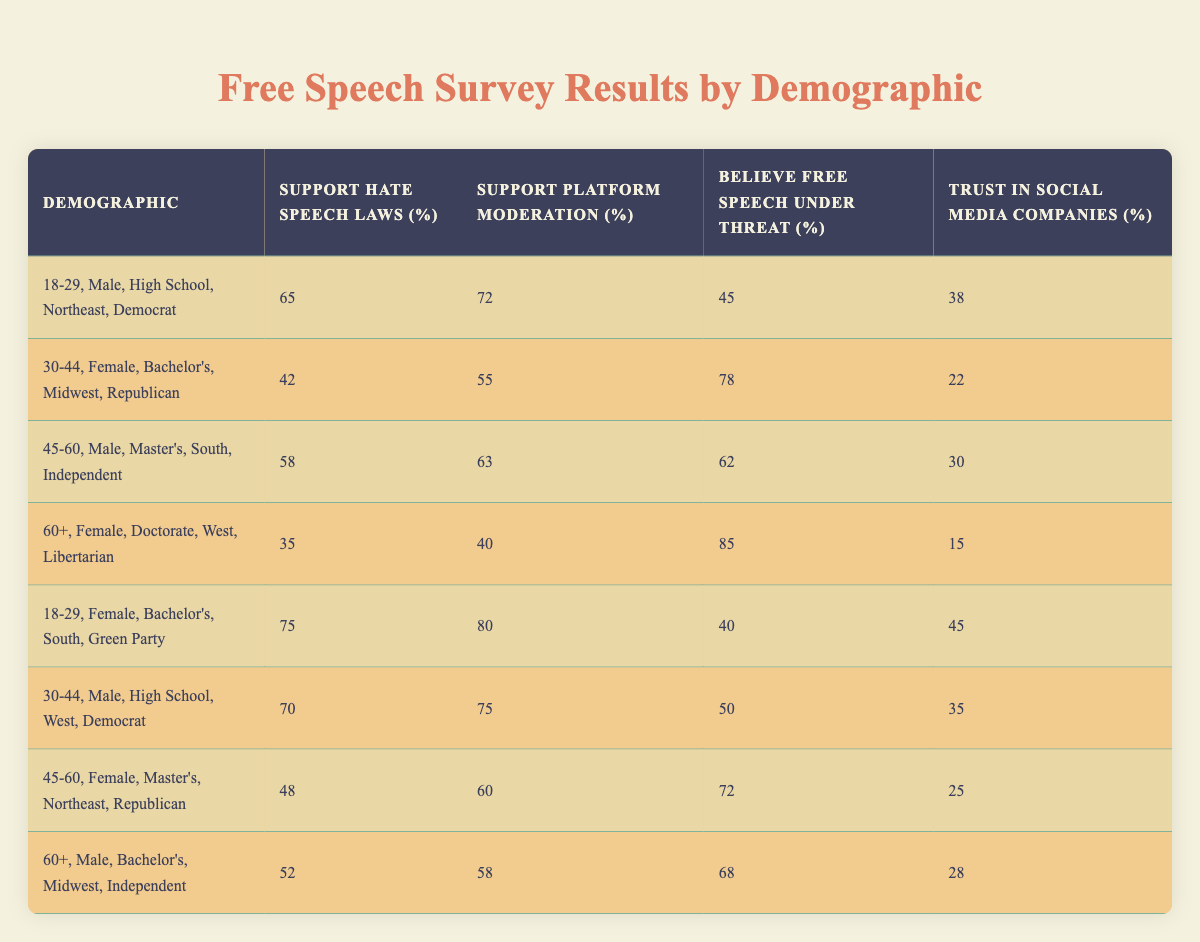What is the highest percentage of support for hate speech laws among the demographics? The demographics with the highest support for hate speech laws is the "18-29, Female, Bachelor's, South, Green Party" at 75%.
Answer: 75 Which demographic believes that free speech is under threat the most? The demographic with the highest belief that free speech is under threat is the "60+, Female, Doctorate, West, Libertarian" at 85%.
Answer: 85 What is the average percentage of trust in social media companies across all demographics? To find the average, add all the trust percentages: (38 + 22 + 30 + 15 + 45 + 35 + 25 + 28) = 238. Then, divide by the number of demographics, which is 8. So, the average is 238/8 = 29.75.
Answer: 29.75 Is there a demographic that has both high support for platform moderation and high belief that free speech is under threat? Yes, the demographic "30-44, Female, Bachelor's, Midwest, Republican" has a support for platform moderation of 55% and a belief that free speech is under threat of 78%, which indicates both points.
Answer: Yes What is the difference in percentage points for support for platform moderation between the youngest (18-29) male and female demographics? The support for platform moderation for "18-29, Male, High School, Northeast, Democrat" is 72%, and for "18-29, Female, Bachelor's, South, Green Party" it is 80%. The difference is calculated as 80% - 72% = 8%.
Answer: 8% Which demographic combination has the lowest trust in social media companies? The demographic with the lowest trust in social media companies is "60+, Female, Doctorate, West, Libertarian" at 15%.
Answer: 15 What is the combined percentage of support for hate speech laws for both males in the 30-44 age category? The support percentages for males in this category are "42%" ("30-44, Female, Bachelor's, Midwest, Republican") and "70%" ("30-44, Male, High School, West, Democrat"). The combined percentage is 42% + 70% = 112%.
Answer: 112 Has any demographic shown a support for hate speech laws over 60%? Yes, there are three demographics showing support over 60%: "18-29, Female, Bachelor's, South, Green Party" at 75%, "30-44, Male, High School, West, Democrat" at 70%, and "18-29, Male, High School, Northeast, Democrat" at 65%.
Answer: Yes 